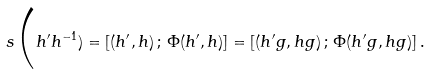Convert formula to latex. <formula><loc_0><loc_0><loc_500><loc_500>s \Big ( h ^ { \prime } h ^ { - 1 } ) = [ ( h ^ { \prime } , h ) \, ; \, \Phi ( h ^ { \prime } , h ) ] = [ ( h ^ { \prime } g , h g ) \, ; \, \Phi ( h ^ { \prime } g , h g ) ] \, .</formula> 